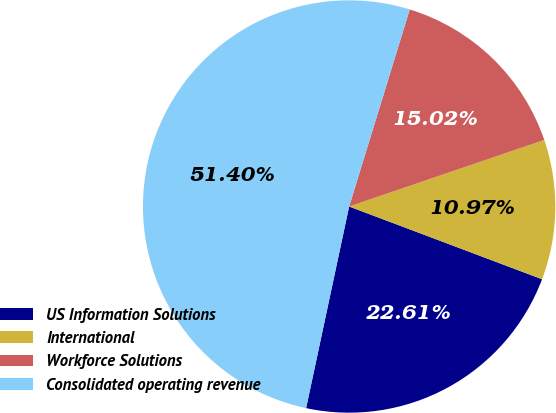Convert chart. <chart><loc_0><loc_0><loc_500><loc_500><pie_chart><fcel>US Information Solutions<fcel>International<fcel>Workforce Solutions<fcel>Consolidated operating revenue<nl><fcel>22.61%<fcel>10.97%<fcel>15.02%<fcel>51.41%<nl></chart> 